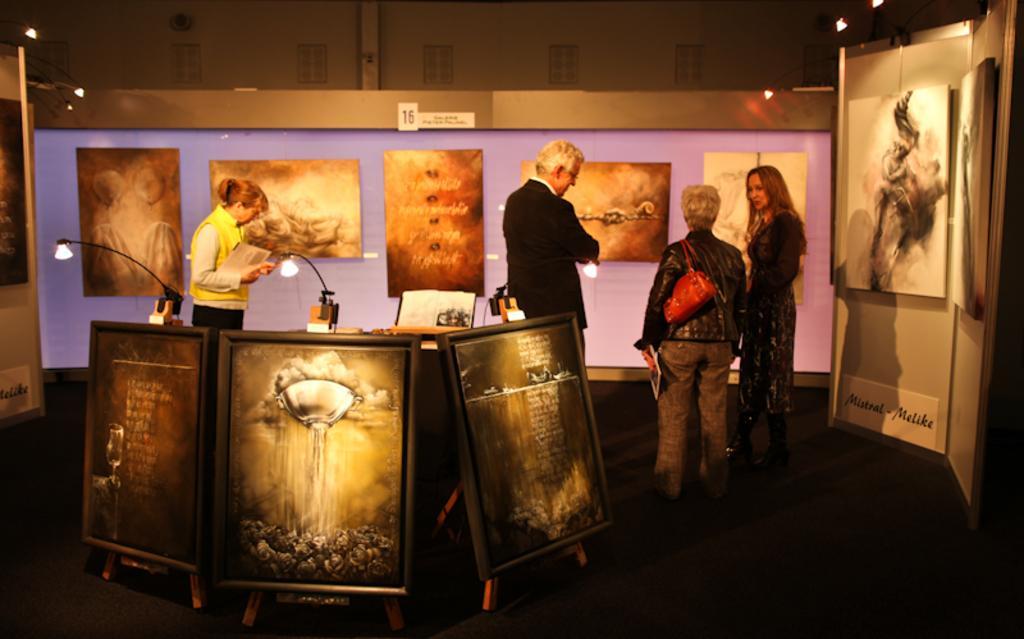Describe this image in one or two sentences. In this picture we can see four people standing on the floor, bag, boards, walls, lights, some objects and in the background we can see windows. 